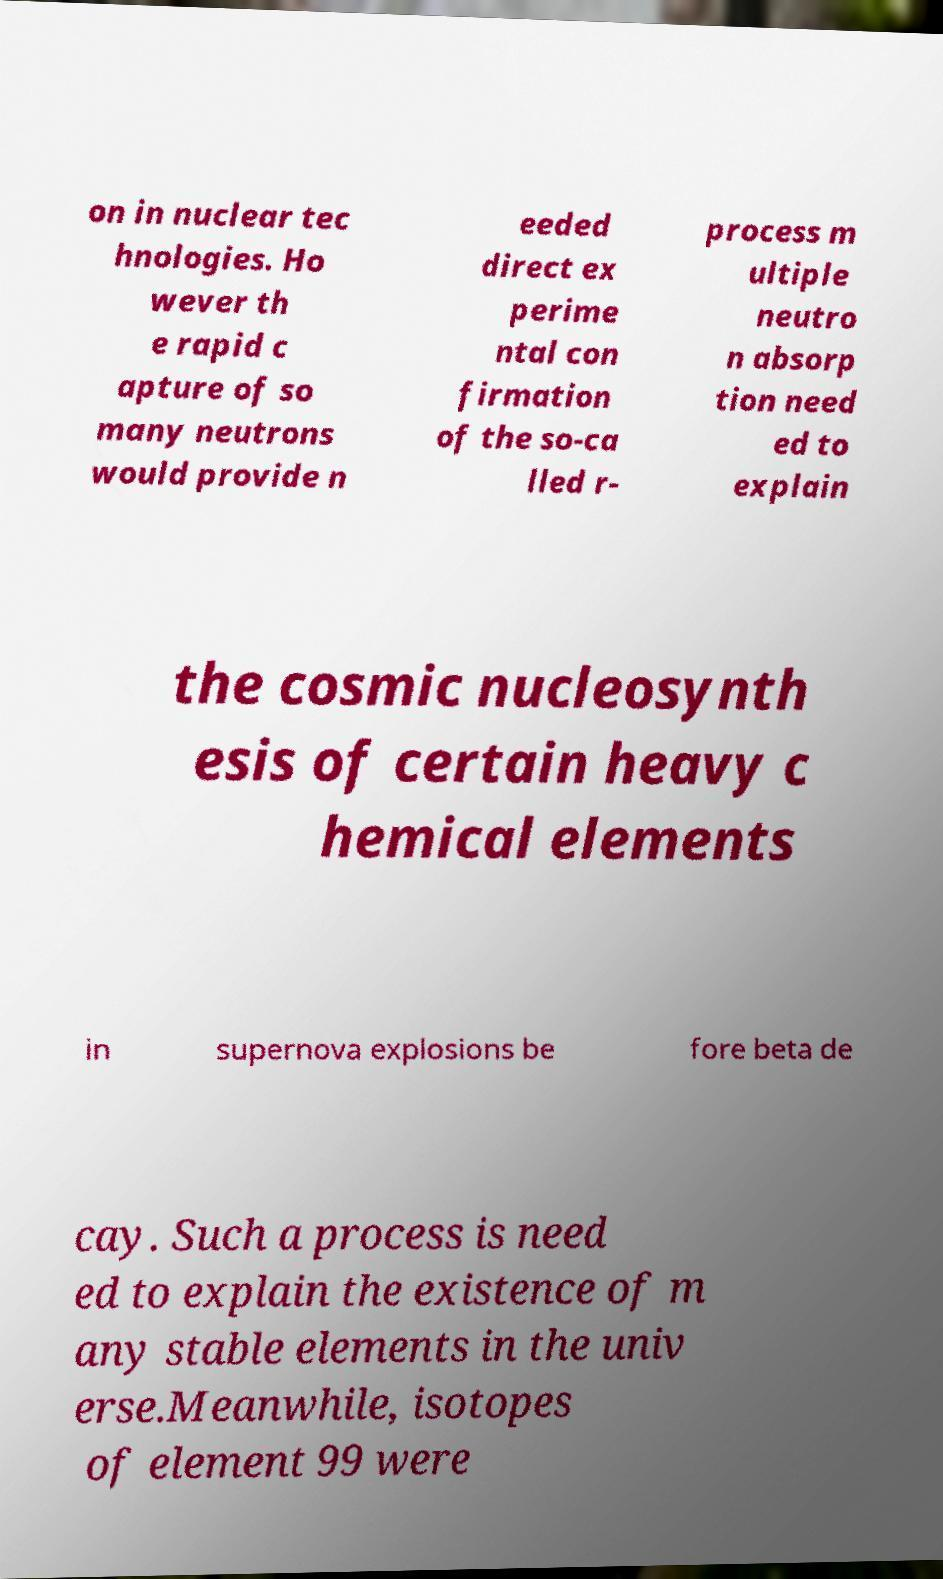Can you read and provide the text displayed in the image?This photo seems to have some interesting text. Can you extract and type it out for me? on in nuclear tec hnologies. Ho wever th e rapid c apture of so many neutrons would provide n eeded direct ex perime ntal con firmation of the so-ca lled r- process m ultiple neutro n absorp tion need ed to explain the cosmic nucleosynth esis of certain heavy c hemical elements in supernova explosions be fore beta de cay. Such a process is need ed to explain the existence of m any stable elements in the univ erse.Meanwhile, isotopes of element 99 were 